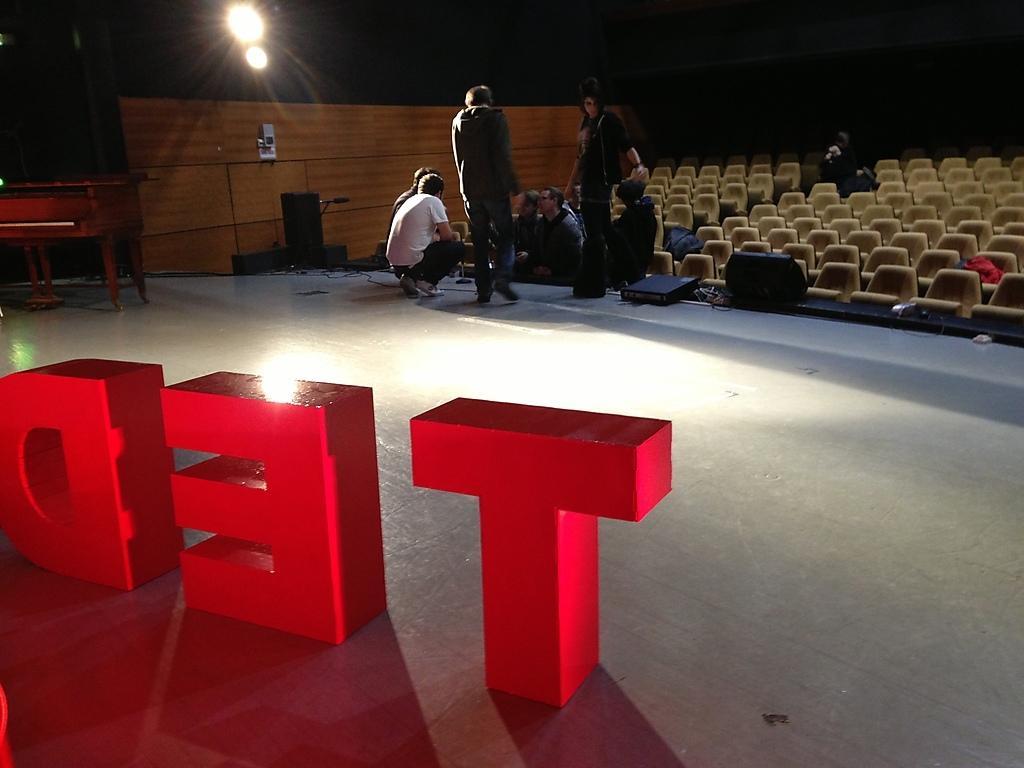Describe this image in one or two sentences. Here in this picture, in the front we can see somethings made into alpha bates present on the floor and in front of that we can see number of people sitting and standing and we can see number of seats present all over the hall and we can also see lights present and we can see a door also present. 